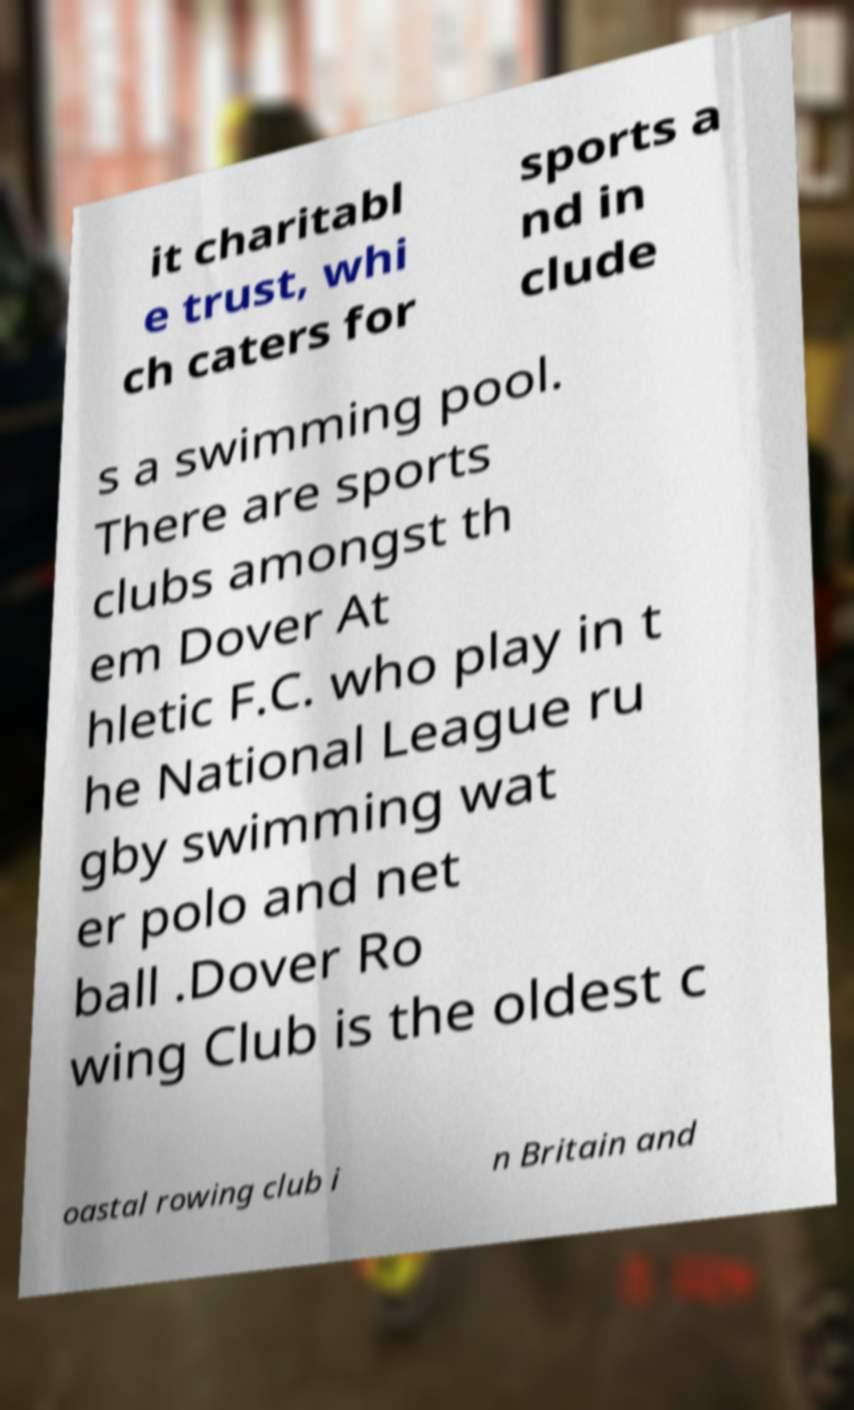What messages or text are displayed in this image? I need them in a readable, typed format. it charitabl e trust, whi ch caters for sports a nd in clude s a swimming pool. There are sports clubs amongst th em Dover At hletic F.C. who play in t he National League ru gby swimming wat er polo and net ball .Dover Ro wing Club is the oldest c oastal rowing club i n Britain and 